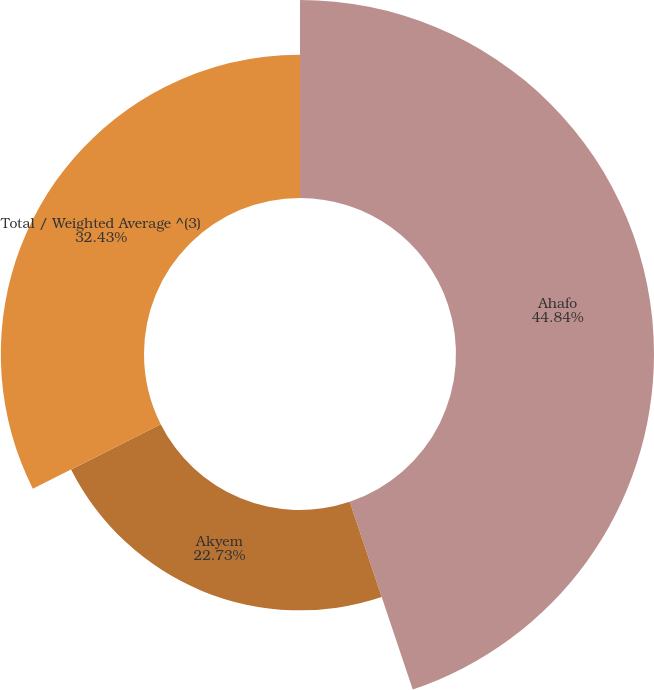Convert chart. <chart><loc_0><loc_0><loc_500><loc_500><pie_chart><fcel>Ahafo<fcel>Akyem<fcel>Total / Weighted Average ^(3)<nl><fcel>44.84%<fcel>22.73%<fcel>32.43%<nl></chart> 